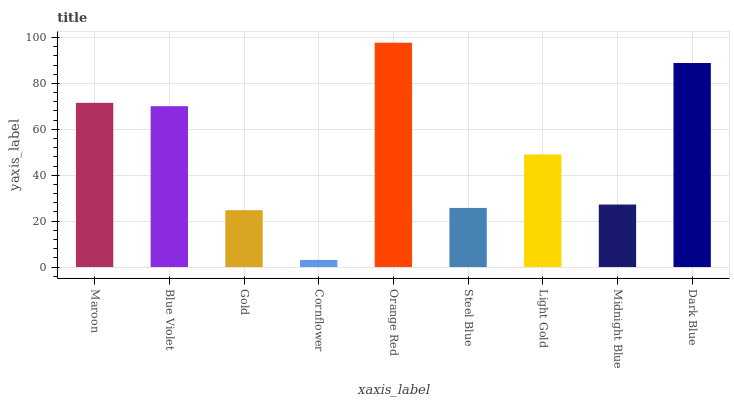Is Cornflower the minimum?
Answer yes or no. Yes. Is Orange Red the maximum?
Answer yes or no. Yes. Is Blue Violet the minimum?
Answer yes or no. No. Is Blue Violet the maximum?
Answer yes or no. No. Is Maroon greater than Blue Violet?
Answer yes or no. Yes. Is Blue Violet less than Maroon?
Answer yes or no. Yes. Is Blue Violet greater than Maroon?
Answer yes or no. No. Is Maroon less than Blue Violet?
Answer yes or no. No. Is Light Gold the high median?
Answer yes or no. Yes. Is Light Gold the low median?
Answer yes or no. Yes. Is Dark Blue the high median?
Answer yes or no. No. Is Gold the low median?
Answer yes or no. No. 